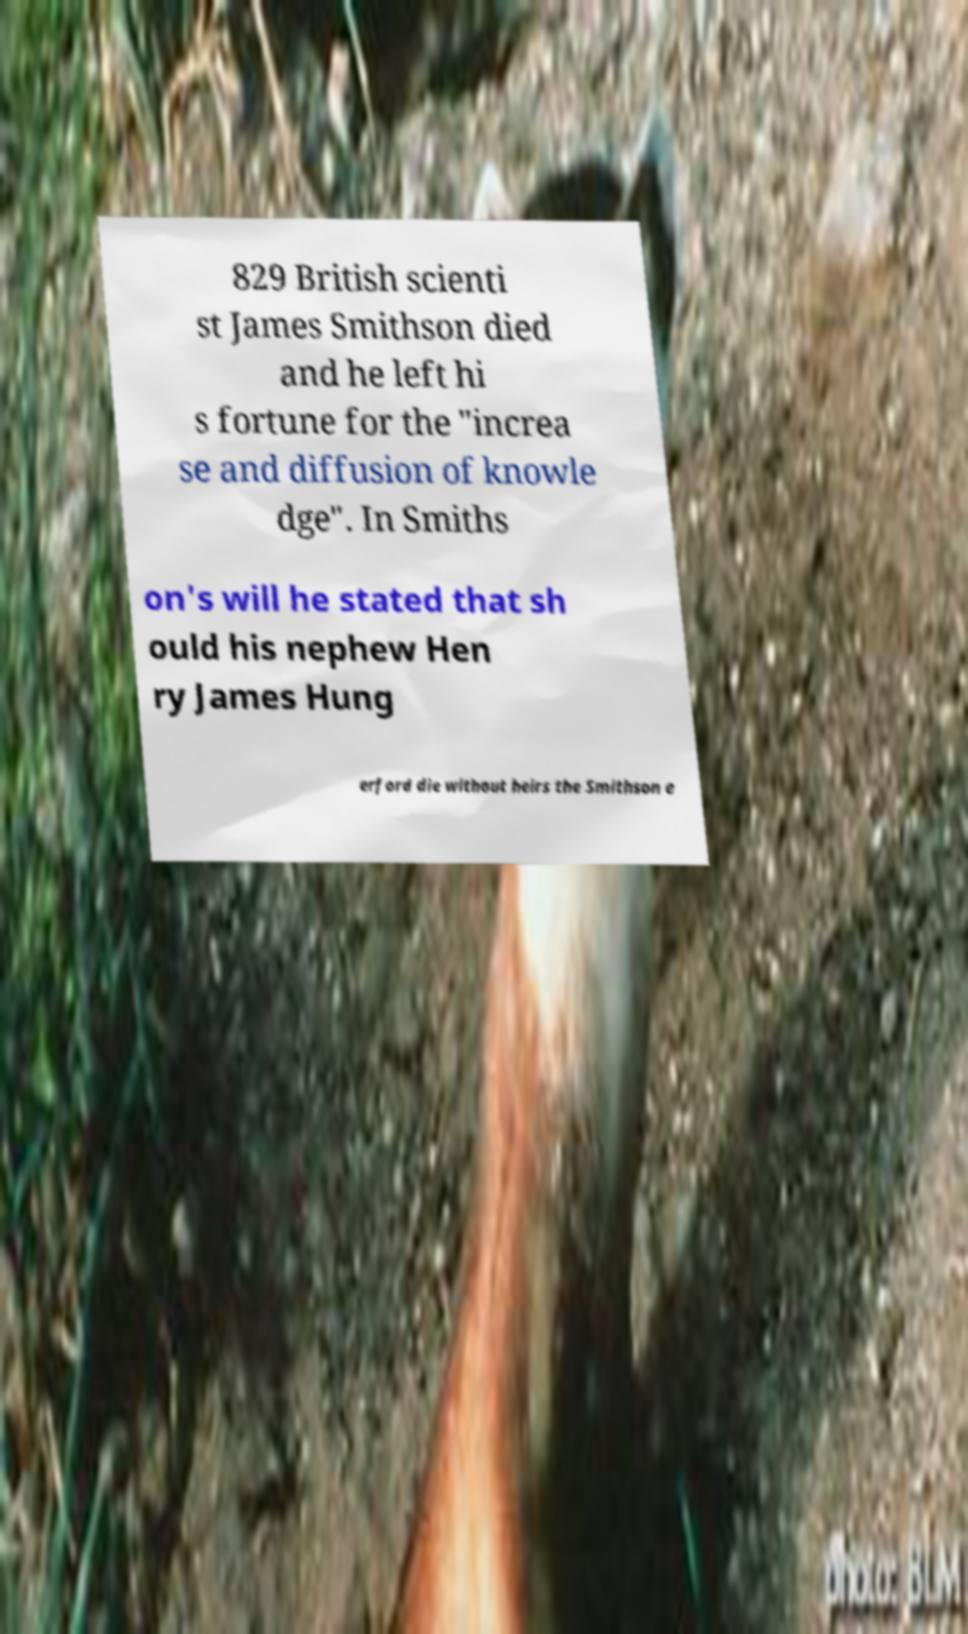Could you extract and type out the text from this image? 829 British scienti st James Smithson died and he left hi s fortune for the "increa se and diffusion of knowle dge". In Smiths on's will he stated that sh ould his nephew Hen ry James Hung erford die without heirs the Smithson e 